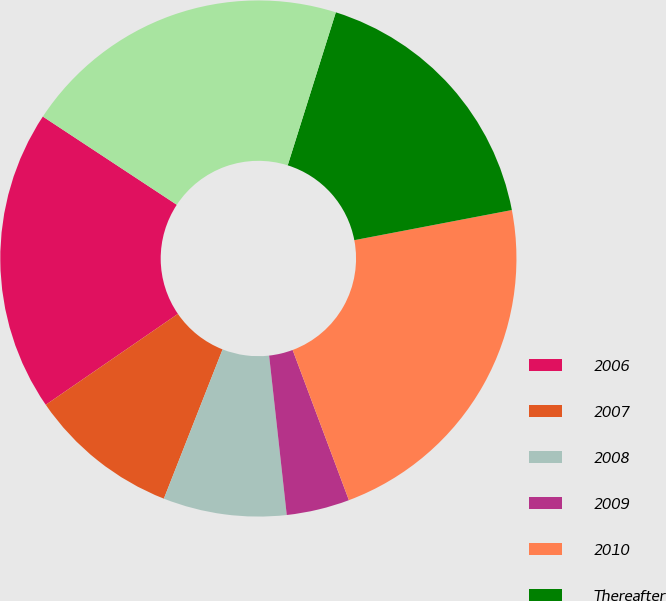Convert chart. <chart><loc_0><loc_0><loc_500><loc_500><pie_chart><fcel>2006<fcel>2007<fcel>2008<fcel>2009<fcel>2010<fcel>Thereafter<fcel>Less-current portion<nl><fcel>18.86%<fcel>9.44%<fcel>7.72%<fcel>3.95%<fcel>22.3%<fcel>17.14%<fcel>20.58%<nl></chart> 